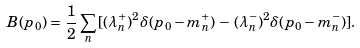<formula> <loc_0><loc_0><loc_500><loc_500>B ( p _ { 0 } ) = \, \frac { 1 } { 2 } \sum _ { n } \, [ ( \lambda _ { n } ^ { + } ) ^ { 2 } \delta ( p _ { 0 } - m _ { n } ^ { + } ) \, - \, ( \lambda _ { n } ^ { - } ) ^ { 2 } \delta ( p _ { 0 } - m _ { n } ^ { - } ) ] .</formula> 